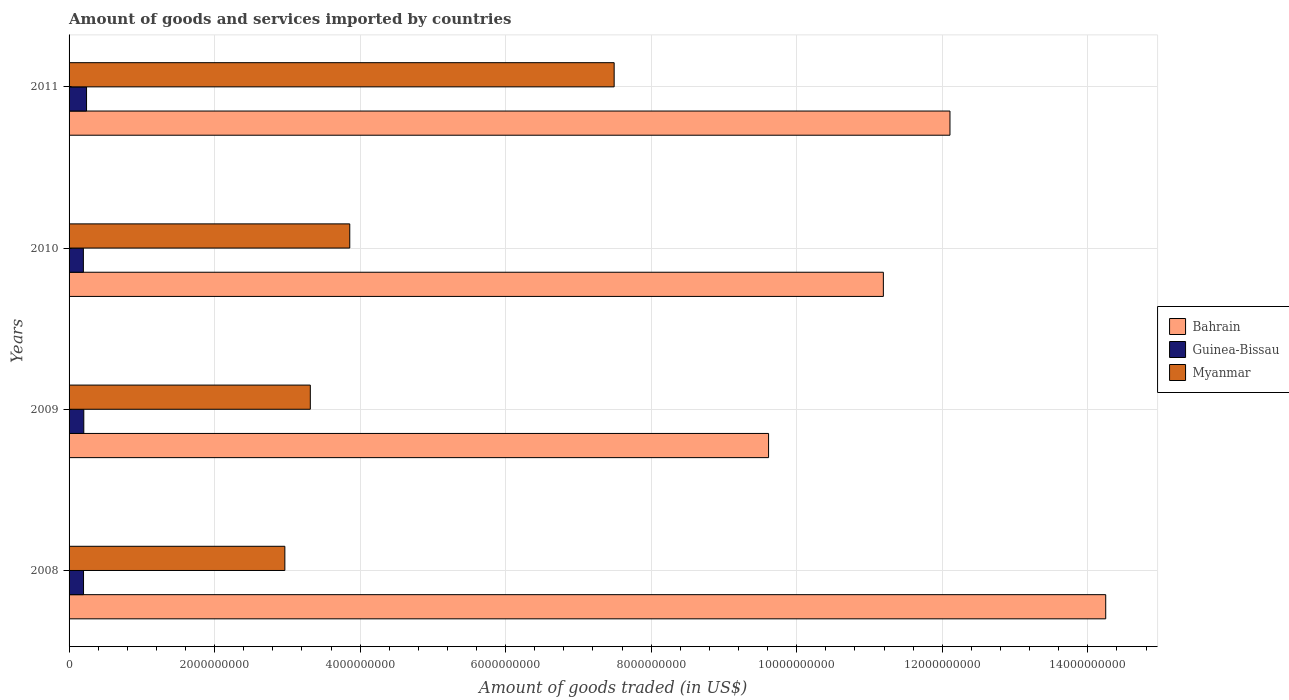How many groups of bars are there?
Give a very brief answer. 4. How many bars are there on the 4th tick from the top?
Make the answer very short. 3. How many bars are there on the 2nd tick from the bottom?
Offer a terse response. 3. In how many cases, is the number of bars for a given year not equal to the number of legend labels?
Your response must be concise. 0. What is the total amount of goods and services imported in Bahrain in 2008?
Provide a short and direct response. 1.42e+1. Across all years, what is the maximum total amount of goods and services imported in Bahrain?
Your answer should be very brief. 1.42e+1. Across all years, what is the minimum total amount of goods and services imported in Guinea-Bissau?
Ensure brevity in your answer.  1.97e+08. In which year was the total amount of goods and services imported in Myanmar maximum?
Offer a terse response. 2011. In which year was the total amount of goods and services imported in Guinea-Bissau minimum?
Provide a short and direct response. 2010. What is the total total amount of goods and services imported in Myanmar in the graph?
Your answer should be very brief. 1.76e+1. What is the difference between the total amount of goods and services imported in Guinea-Bissau in 2008 and that in 2011?
Offer a terse response. -4.14e+07. What is the difference between the total amount of goods and services imported in Guinea-Bissau in 2011 and the total amount of goods and services imported in Myanmar in 2008?
Ensure brevity in your answer.  -2.73e+09. What is the average total amount of goods and services imported in Myanmar per year?
Offer a terse response. 4.41e+09. In the year 2009, what is the difference between the total amount of goods and services imported in Myanmar and total amount of goods and services imported in Bahrain?
Offer a terse response. -6.30e+09. In how many years, is the total amount of goods and services imported in Guinea-Bissau greater than 2400000000 US$?
Your response must be concise. 0. What is the ratio of the total amount of goods and services imported in Guinea-Bissau in 2009 to that in 2011?
Ensure brevity in your answer.  0.84. What is the difference between the highest and the second highest total amount of goods and services imported in Bahrain?
Give a very brief answer. 2.14e+09. What is the difference between the highest and the lowest total amount of goods and services imported in Bahrain?
Your response must be concise. 4.63e+09. Is the sum of the total amount of goods and services imported in Myanmar in 2008 and 2011 greater than the maximum total amount of goods and services imported in Guinea-Bissau across all years?
Provide a short and direct response. Yes. What does the 2nd bar from the top in 2009 represents?
Your answer should be compact. Guinea-Bissau. What does the 2nd bar from the bottom in 2009 represents?
Make the answer very short. Guinea-Bissau. What is the difference between two consecutive major ticks on the X-axis?
Provide a short and direct response. 2.00e+09. Are the values on the major ticks of X-axis written in scientific E-notation?
Make the answer very short. No. Does the graph contain grids?
Offer a very short reply. Yes. How many legend labels are there?
Your answer should be very brief. 3. What is the title of the graph?
Make the answer very short. Amount of goods and services imported by countries. What is the label or title of the X-axis?
Provide a succinct answer. Amount of goods traded (in US$). What is the Amount of goods traded (in US$) in Bahrain in 2008?
Your answer should be compact. 1.42e+1. What is the Amount of goods traded (in US$) in Guinea-Bissau in 2008?
Ensure brevity in your answer.  1.99e+08. What is the Amount of goods traded (in US$) in Myanmar in 2008?
Your answer should be compact. 2.97e+09. What is the Amount of goods traded (in US$) of Bahrain in 2009?
Keep it short and to the point. 9.61e+09. What is the Amount of goods traded (in US$) of Guinea-Bissau in 2009?
Provide a short and direct response. 2.02e+08. What is the Amount of goods traded (in US$) in Myanmar in 2009?
Your answer should be very brief. 3.32e+09. What is the Amount of goods traded (in US$) of Bahrain in 2010?
Provide a succinct answer. 1.12e+1. What is the Amount of goods traded (in US$) of Guinea-Bissau in 2010?
Make the answer very short. 1.97e+08. What is the Amount of goods traded (in US$) of Myanmar in 2010?
Make the answer very short. 3.86e+09. What is the Amount of goods traded (in US$) in Bahrain in 2011?
Offer a very short reply. 1.21e+1. What is the Amount of goods traded (in US$) in Guinea-Bissau in 2011?
Provide a succinct answer. 2.40e+08. What is the Amount of goods traded (in US$) in Myanmar in 2011?
Give a very brief answer. 7.49e+09. Across all years, what is the maximum Amount of goods traded (in US$) in Bahrain?
Make the answer very short. 1.42e+1. Across all years, what is the maximum Amount of goods traded (in US$) in Guinea-Bissau?
Give a very brief answer. 2.40e+08. Across all years, what is the maximum Amount of goods traded (in US$) of Myanmar?
Keep it short and to the point. 7.49e+09. Across all years, what is the minimum Amount of goods traded (in US$) of Bahrain?
Ensure brevity in your answer.  9.61e+09. Across all years, what is the minimum Amount of goods traded (in US$) in Guinea-Bissau?
Offer a very short reply. 1.97e+08. Across all years, what is the minimum Amount of goods traded (in US$) in Myanmar?
Ensure brevity in your answer.  2.97e+09. What is the total Amount of goods traded (in US$) of Bahrain in the graph?
Your answer should be compact. 4.72e+1. What is the total Amount of goods traded (in US$) of Guinea-Bissau in the graph?
Offer a very short reply. 8.38e+08. What is the total Amount of goods traded (in US$) of Myanmar in the graph?
Ensure brevity in your answer.  1.76e+1. What is the difference between the Amount of goods traded (in US$) in Bahrain in 2008 and that in 2009?
Provide a short and direct response. 4.63e+09. What is the difference between the Amount of goods traded (in US$) in Guinea-Bissau in 2008 and that in 2009?
Your answer should be compact. -3.53e+06. What is the difference between the Amount of goods traded (in US$) of Myanmar in 2008 and that in 2009?
Provide a succinct answer. -3.50e+08. What is the difference between the Amount of goods traded (in US$) in Bahrain in 2008 and that in 2010?
Ensure brevity in your answer.  3.06e+09. What is the difference between the Amount of goods traded (in US$) in Guinea-Bissau in 2008 and that in 2010?
Provide a short and direct response. 2.22e+06. What is the difference between the Amount of goods traded (in US$) in Myanmar in 2008 and that in 2010?
Give a very brief answer. -8.92e+08. What is the difference between the Amount of goods traded (in US$) of Bahrain in 2008 and that in 2011?
Your response must be concise. 2.14e+09. What is the difference between the Amount of goods traded (in US$) in Guinea-Bissau in 2008 and that in 2011?
Your response must be concise. -4.14e+07. What is the difference between the Amount of goods traded (in US$) of Myanmar in 2008 and that in 2011?
Your answer should be very brief. -4.53e+09. What is the difference between the Amount of goods traded (in US$) of Bahrain in 2009 and that in 2010?
Your answer should be very brief. -1.58e+09. What is the difference between the Amount of goods traded (in US$) in Guinea-Bissau in 2009 and that in 2010?
Your answer should be very brief. 5.75e+06. What is the difference between the Amount of goods traded (in US$) of Myanmar in 2009 and that in 2010?
Ensure brevity in your answer.  -5.42e+08. What is the difference between the Amount of goods traded (in US$) in Bahrain in 2009 and that in 2011?
Ensure brevity in your answer.  -2.49e+09. What is the difference between the Amount of goods traded (in US$) of Guinea-Bissau in 2009 and that in 2011?
Make the answer very short. -3.79e+07. What is the difference between the Amount of goods traded (in US$) of Myanmar in 2009 and that in 2011?
Make the answer very short. -4.18e+09. What is the difference between the Amount of goods traded (in US$) of Bahrain in 2010 and that in 2011?
Provide a succinct answer. -9.15e+08. What is the difference between the Amount of goods traded (in US$) in Guinea-Bissau in 2010 and that in 2011?
Provide a succinct answer. -4.36e+07. What is the difference between the Amount of goods traded (in US$) of Myanmar in 2010 and that in 2011?
Ensure brevity in your answer.  -3.63e+09. What is the difference between the Amount of goods traded (in US$) of Bahrain in 2008 and the Amount of goods traded (in US$) of Guinea-Bissau in 2009?
Provide a succinct answer. 1.40e+1. What is the difference between the Amount of goods traded (in US$) in Bahrain in 2008 and the Amount of goods traded (in US$) in Myanmar in 2009?
Ensure brevity in your answer.  1.09e+1. What is the difference between the Amount of goods traded (in US$) of Guinea-Bissau in 2008 and the Amount of goods traded (in US$) of Myanmar in 2009?
Your answer should be very brief. -3.12e+09. What is the difference between the Amount of goods traded (in US$) in Bahrain in 2008 and the Amount of goods traded (in US$) in Guinea-Bissau in 2010?
Make the answer very short. 1.40e+1. What is the difference between the Amount of goods traded (in US$) of Bahrain in 2008 and the Amount of goods traded (in US$) of Myanmar in 2010?
Provide a short and direct response. 1.04e+1. What is the difference between the Amount of goods traded (in US$) in Guinea-Bissau in 2008 and the Amount of goods traded (in US$) in Myanmar in 2010?
Offer a very short reply. -3.66e+09. What is the difference between the Amount of goods traded (in US$) in Bahrain in 2008 and the Amount of goods traded (in US$) in Guinea-Bissau in 2011?
Your response must be concise. 1.40e+1. What is the difference between the Amount of goods traded (in US$) in Bahrain in 2008 and the Amount of goods traded (in US$) in Myanmar in 2011?
Keep it short and to the point. 6.76e+09. What is the difference between the Amount of goods traded (in US$) in Guinea-Bissau in 2008 and the Amount of goods traded (in US$) in Myanmar in 2011?
Make the answer very short. -7.29e+09. What is the difference between the Amount of goods traded (in US$) of Bahrain in 2009 and the Amount of goods traded (in US$) of Guinea-Bissau in 2010?
Provide a succinct answer. 9.42e+09. What is the difference between the Amount of goods traded (in US$) of Bahrain in 2009 and the Amount of goods traded (in US$) of Myanmar in 2010?
Ensure brevity in your answer.  5.76e+09. What is the difference between the Amount of goods traded (in US$) of Guinea-Bissau in 2009 and the Amount of goods traded (in US$) of Myanmar in 2010?
Offer a very short reply. -3.66e+09. What is the difference between the Amount of goods traded (in US$) of Bahrain in 2009 and the Amount of goods traded (in US$) of Guinea-Bissau in 2011?
Provide a short and direct response. 9.37e+09. What is the difference between the Amount of goods traded (in US$) in Bahrain in 2009 and the Amount of goods traded (in US$) in Myanmar in 2011?
Provide a succinct answer. 2.12e+09. What is the difference between the Amount of goods traded (in US$) of Guinea-Bissau in 2009 and the Amount of goods traded (in US$) of Myanmar in 2011?
Your response must be concise. -7.29e+09. What is the difference between the Amount of goods traded (in US$) of Bahrain in 2010 and the Amount of goods traded (in US$) of Guinea-Bissau in 2011?
Give a very brief answer. 1.10e+1. What is the difference between the Amount of goods traded (in US$) in Bahrain in 2010 and the Amount of goods traded (in US$) in Myanmar in 2011?
Make the answer very short. 3.70e+09. What is the difference between the Amount of goods traded (in US$) in Guinea-Bissau in 2010 and the Amount of goods traded (in US$) in Myanmar in 2011?
Offer a very short reply. -7.29e+09. What is the average Amount of goods traded (in US$) in Bahrain per year?
Provide a succinct answer. 1.18e+1. What is the average Amount of goods traded (in US$) in Guinea-Bissau per year?
Keep it short and to the point. 2.09e+08. What is the average Amount of goods traded (in US$) of Myanmar per year?
Make the answer very short. 4.41e+09. In the year 2008, what is the difference between the Amount of goods traded (in US$) of Bahrain and Amount of goods traded (in US$) of Guinea-Bissau?
Your answer should be very brief. 1.40e+1. In the year 2008, what is the difference between the Amount of goods traded (in US$) of Bahrain and Amount of goods traded (in US$) of Myanmar?
Your answer should be compact. 1.13e+1. In the year 2008, what is the difference between the Amount of goods traded (in US$) in Guinea-Bissau and Amount of goods traded (in US$) in Myanmar?
Ensure brevity in your answer.  -2.77e+09. In the year 2009, what is the difference between the Amount of goods traded (in US$) of Bahrain and Amount of goods traded (in US$) of Guinea-Bissau?
Make the answer very short. 9.41e+09. In the year 2009, what is the difference between the Amount of goods traded (in US$) in Bahrain and Amount of goods traded (in US$) in Myanmar?
Your answer should be very brief. 6.30e+09. In the year 2009, what is the difference between the Amount of goods traded (in US$) of Guinea-Bissau and Amount of goods traded (in US$) of Myanmar?
Provide a succinct answer. -3.11e+09. In the year 2010, what is the difference between the Amount of goods traded (in US$) of Bahrain and Amount of goods traded (in US$) of Guinea-Bissau?
Make the answer very short. 1.10e+1. In the year 2010, what is the difference between the Amount of goods traded (in US$) of Bahrain and Amount of goods traded (in US$) of Myanmar?
Your response must be concise. 7.33e+09. In the year 2010, what is the difference between the Amount of goods traded (in US$) in Guinea-Bissau and Amount of goods traded (in US$) in Myanmar?
Make the answer very short. -3.66e+09. In the year 2011, what is the difference between the Amount of goods traded (in US$) of Bahrain and Amount of goods traded (in US$) of Guinea-Bissau?
Ensure brevity in your answer.  1.19e+1. In the year 2011, what is the difference between the Amount of goods traded (in US$) of Bahrain and Amount of goods traded (in US$) of Myanmar?
Make the answer very short. 4.61e+09. In the year 2011, what is the difference between the Amount of goods traded (in US$) of Guinea-Bissau and Amount of goods traded (in US$) of Myanmar?
Provide a succinct answer. -7.25e+09. What is the ratio of the Amount of goods traded (in US$) of Bahrain in 2008 to that in 2009?
Keep it short and to the point. 1.48. What is the ratio of the Amount of goods traded (in US$) in Guinea-Bissau in 2008 to that in 2009?
Provide a short and direct response. 0.98. What is the ratio of the Amount of goods traded (in US$) of Myanmar in 2008 to that in 2009?
Offer a very short reply. 0.89. What is the ratio of the Amount of goods traded (in US$) of Bahrain in 2008 to that in 2010?
Ensure brevity in your answer.  1.27. What is the ratio of the Amount of goods traded (in US$) in Guinea-Bissau in 2008 to that in 2010?
Your answer should be compact. 1.01. What is the ratio of the Amount of goods traded (in US$) in Myanmar in 2008 to that in 2010?
Your answer should be very brief. 0.77. What is the ratio of the Amount of goods traded (in US$) in Bahrain in 2008 to that in 2011?
Offer a very short reply. 1.18. What is the ratio of the Amount of goods traded (in US$) in Guinea-Bissau in 2008 to that in 2011?
Ensure brevity in your answer.  0.83. What is the ratio of the Amount of goods traded (in US$) in Myanmar in 2008 to that in 2011?
Make the answer very short. 0.4. What is the ratio of the Amount of goods traded (in US$) in Bahrain in 2009 to that in 2010?
Offer a very short reply. 0.86. What is the ratio of the Amount of goods traded (in US$) of Guinea-Bissau in 2009 to that in 2010?
Give a very brief answer. 1.03. What is the ratio of the Amount of goods traded (in US$) of Myanmar in 2009 to that in 2010?
Give a very brief answer. 0.86. What is the ratio of the Amount of goods traded (in US$) in Bahrain in 2009 to that in 2011?
Provide a succinct answer. 0.79. What is the ratio of the Amount of goods traded (in US$) of Guinea-Bissau in 2009 to that in 2011?
Provide a succinct answer. 0.84. What is the ratio of the Amount of goods traded (in US$) of Myanmar in 2009 to that in 2011?
Provide a short and direct response. 0.44. What is the ratio of the Amount of goods traded (in US$) of Bahrain in 2010 to that in 2011?
Ensure brevity in your answer.  0.92. What is the ratio of the Amount of goods traded (in US$) in Guinea-Bissau in 2010 to that in 2011?
Your answer should be very brief. 0.82. What is the ratio of the Amount of goods traded (in US$) in Myanmar in 2010 to that in 2011?
Your answer should be very brief. 0.52. What is the difference between the highest and the second highest Amount of goods traded (in US$) of Bahrain?
Your response must be concise. 2.14e+09. What is the difference between the highest and the second highest Amount of goods traded (in US$) of Guinea-Bissau?
Provide a short and direct response. 3.79e+07. What is the difference between the highest and the second highest Amount of goods traded (in US$) in Myanmar?
Keep it short and to the point. 3.63e+09. What is the difference between the highest and the lowest Amount of goods traded (in US$) in Bahrain?
Offer a very short reply. 4.63e+09. What is the difference between the highest and the lowest Amount of goods traded (in US$) of Guinea-Bissau?
Your answer should be compact. 4.36e+07. What is the difference between the highest and the lowest Amount of goods traded (in US$) in Myanmar?
Provide a succinct answer. 4.53e+09. 